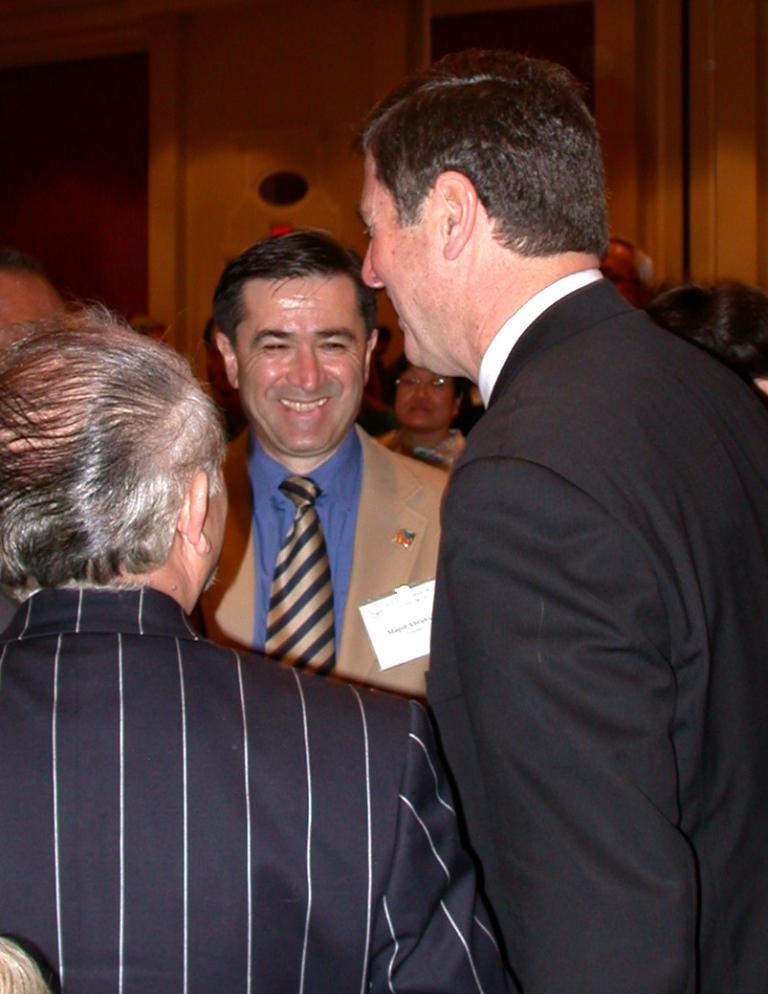How many people are present in the image? There are many people in the image. Can you identify any specific features of one of the people? One person is wearing a badge. What can be seen in the background of the image? There is a wooden wall in the background of the image. What type of thunder can be heard in the image? There is no sound present in the image, so it is not possible to determine if any thunder can be heard. 